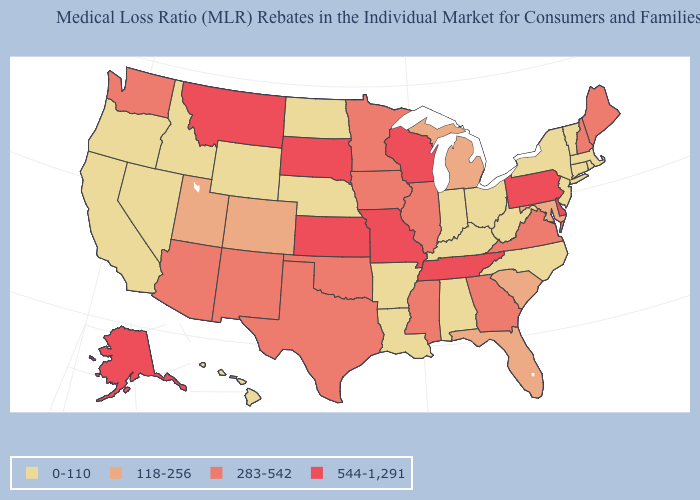Among the states that border Louisiana , does Mississippi have the highest value?
Answer briefly. Yes. What is the value of New York?
Be succinct. 0-110. How many symbols are there in the legend?
Give a very brief answer. 4. Does North Dakota have the highest value in the USA?
Give a very brief answer. No. Which states have the lowest value in the MidWest?
Concise answer only. Indiana, Nebraska, North Dakota, Ohio. Which states hav the highest value in the West?
Short answer required. Alaska, Montana. What is the lowest value in the South?
Give a very brief answer. 0-110. What is the value of Missouri?
Concise answer only. 544-1,291. What is the value of Louisiana?
Concise answer only. 0-110. Among the states that border Wisconsin , which have the highest value?
Give a very brief answer. Illinois, Iowa, Minnesota. Name the states that have a value in the range 544-1,291?
Concise answer only. Alaska, Delaware, Kansas, Missouri, Montana, Pennsylvania, South Dakota, Tennessee, Wisconsin. What is the value of Alaska?
Concise answer only. 544-1,291. Does Ohio have the lowest value in the MidWest?
Give a very brief answer. Yes. What is the lowest value in the USA?
Give a very brief answer. 0-110. 